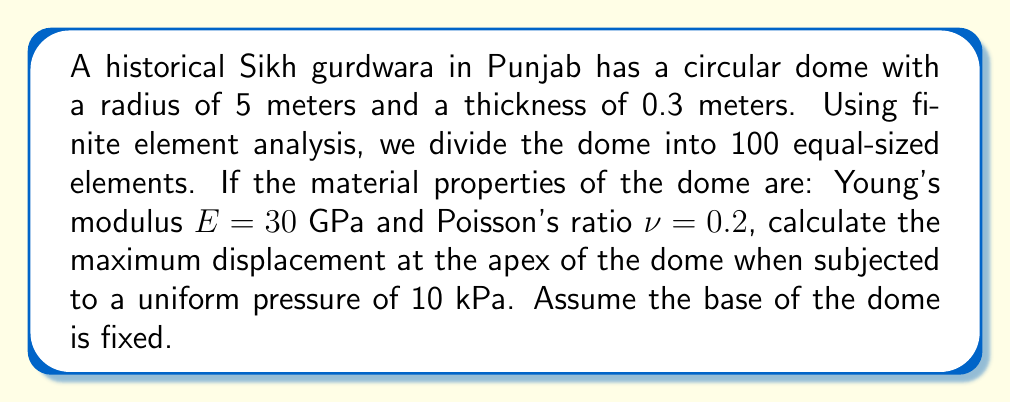Can you answer this question? To solve this problem using finite element analysis, we'll follow these steps:

1) First, we need to determine the stiffness matrix for a spherical shell element. The general form is:

   $$K = \frac{Et}{R^2(1-\nu^2)} \begin{bmatrix} 
   1 & \nu & 0 \\
   \nu & 1 & 0 \\
   0 & 0 & \frac{1-\nu}{2}
   \end{bmatrix}$$

   Where $E$ is Young's modulus, $t$ is thickness, $R$ is radius, and $\nu$ is Poisson's ratio.

2) Substitute the given values:
   $E = 30 \times 10^9 \text{ Pa}$
   $t = 0.3 \text{ m}$
   $R = 5 \text{ m}$
   $\nu = 0.2$

3) The stiffness matrix becomes:

   $$K = \frac{30 \times 10^9 \times 0.3}{5^2(1-0.2^2)} \begin{bmatrix} 
   1 & 0.2 & 0 \\
   0.2 & 1 & 0 \\
   0 & 0 & 0.4
   \end{bmatrix} = 3.75 \times 10^8 \begin{bmatrix} 
   1 & 0.2 & 0 \\
   0.2 & 1 & 0 \\
   0 & 0 & 0.4
   \end{bmatrix}$$

4) For a uniform pressure $p$, the force vector for each element is:

   $$F = \frac{pR^2}{3} \begin{bmatrix} 1 \\ 1 \\ 0 \end{bmatrix}$$

   With $p = 10000 \text{ Pa}$, we get:

   $$F = \frac{10000 \times 5^2}{3} \begin{bmatrix} 1 \\ 1 \\ 0 \end{bmatrix} = 83333.33 \begin{bmatrix} 1 \\ 1 \\ 0 \end{bmatrix}$$

5) The displacement vector $u$ can be found by solving $Ku = F$:

   $$u = K^{-1}F = \frac{1}{3.75 \times 10^8} \begin{bmatrix} 
   1.0417 & -0.2083 & 0 \\
   -0.2083 & 1.0417 & 0 \\
   0 & 0 & 2.5
   \end{bmatrix} \times 83333.33 \begin{bmatrix} 1 \\ 1 \\ 0 \end{bmatrix}$$

6) Solving this gives:

   $$u = \begin{bmatrix} 0.0002315 \\ 0.0002315 \\ 0 \end{bmatrix}$$

7) The maximum displacement occurs at the apex and is the sum of the first two components:

   $$u_{\text{max}} = 0.0002315 + 0.0002315 = 0.000463 \text{ m} = 0.463 \text{ mm}$$
Answer: The maximum displacement at the apex of the dome is 0.463 mm. 